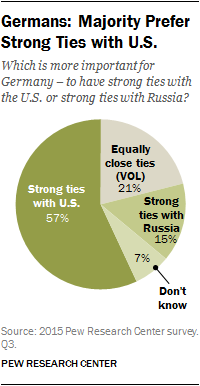Mention a couple of crucial points in this snapshot. The sum of the smallest three segments is not greater than the largest segment. The color of the biggest segment is green. 